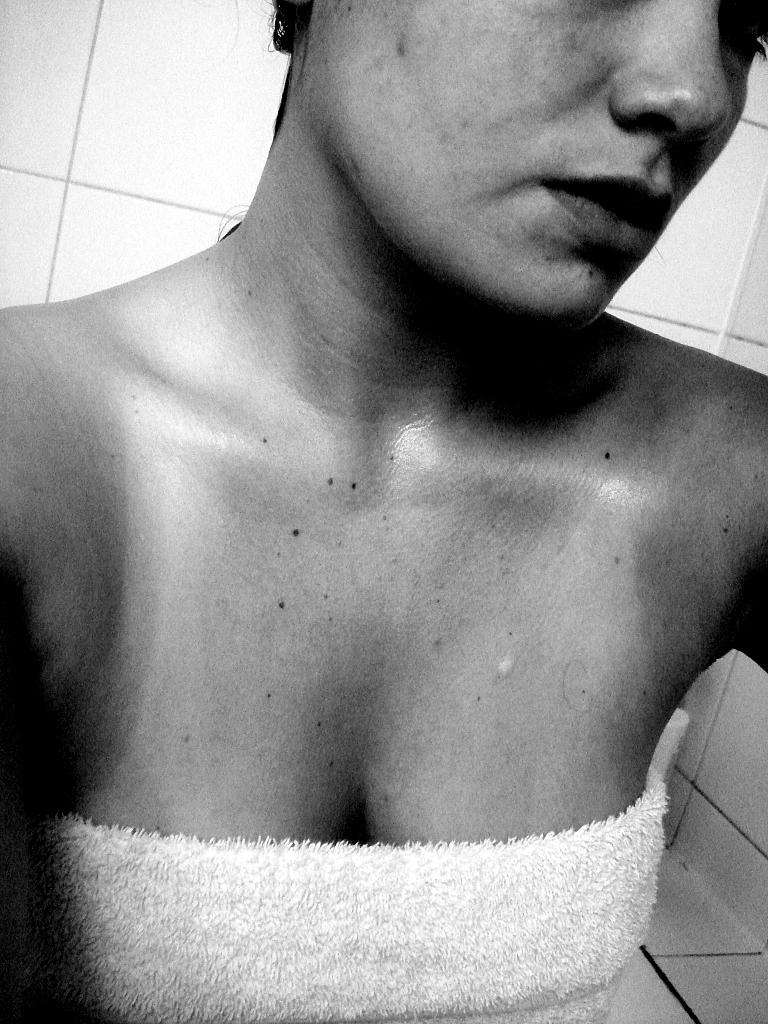Who or what is the main subject of the image? There is a person in the image. What is the person wearing? The person is wearing a dress. What can be seen in the background of the image? There is a wall in the background of the image. What is the color scheme of the image? The image is black and white. Where is the coat hanging in the image? There is no coat present in the image. How many mailboxes are visible in the image? There are no mailboxes visible in the image. 